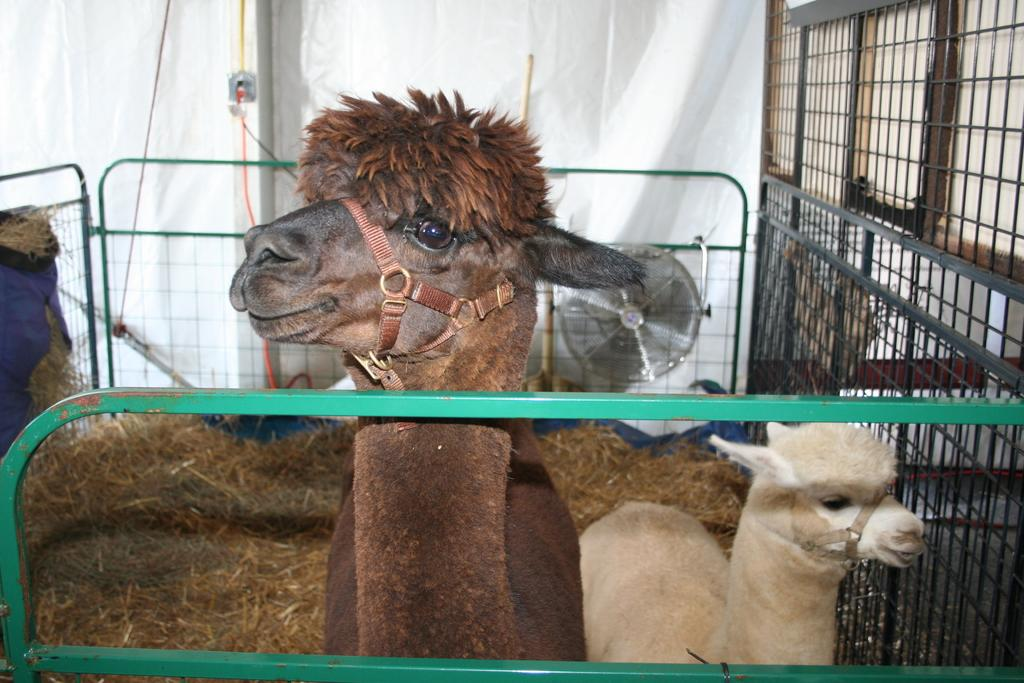How many llamas are in the image? There are two llamas in the image. What are the colors of the llamas? One llama is brown in color, and the other is white in color. What type of structure can be seen in the image? There is an iron gate in the image. What is the color of the grass in the image? The grass in the image is yellow. What object is visible in the background of the image? There is a fan visible in the background of the image. How many ears of corn can be seen in the image? There are no ears of corn present in the image. Are there any dogs or children visible in the image? No, there are no dogs or children visible in the image; it features two llamas, an iron gate, yellow grass, and a fan in the background. 